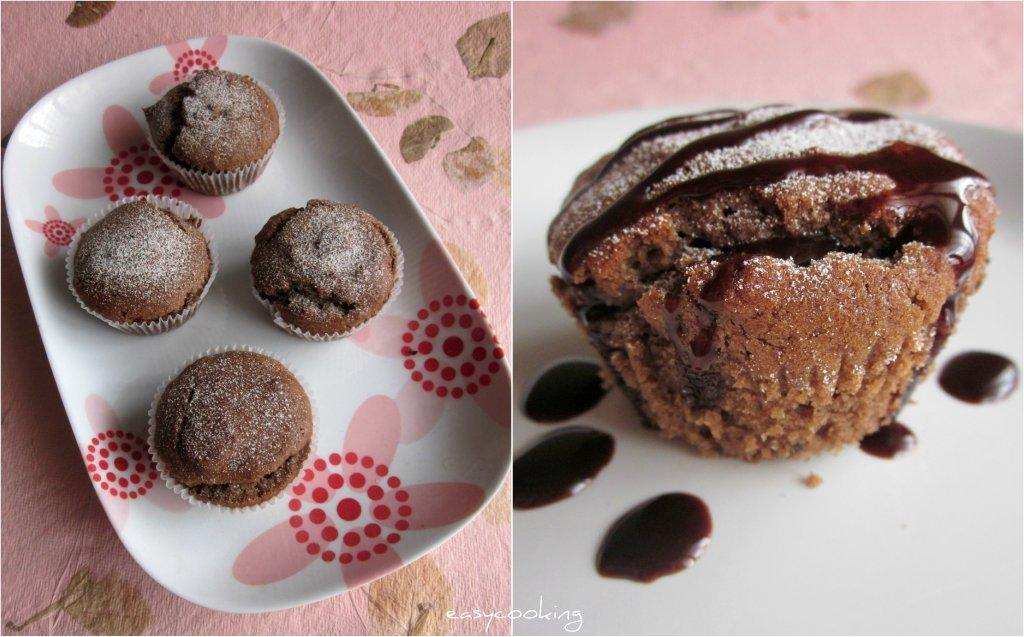How many cupcakes are visible in the image? There are four cupcakes in a tray on the left side of the image, and one cupcake in a tray on the right side of the image. What other items can be seen on the right side of the image? There are chocolate drops in a tray on the right side of the image. What type of quill is used to decorate the cupcakes in the image? There is no quill present in the image; the cupcakes and chocolate drops are the only items visible. 